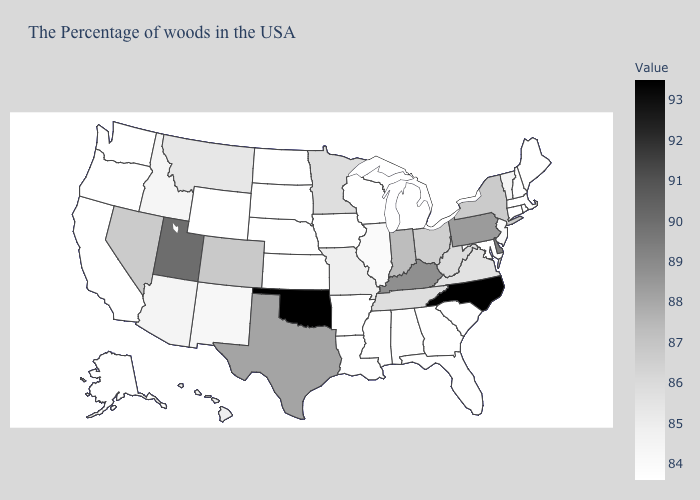Among the states that border Maryland , does Delaware have the highest value?
Concise answer only. Yes. Which states have the highest value in the USA?
Concise answer only. North Carolina, Oklahoma. Does Oklahoma have the highest value in the USA?
Short answer required. Yes. Is the legend a continuous bar?
Give a very brief answer. Yes. Among the states that border Maryland , which have the highest value?
Concise answer only. Delaware. Does South Carolina have the lowest value in the USA?
Be succinct. Yes. Does the map have missing data?
Keep it brief. No. 